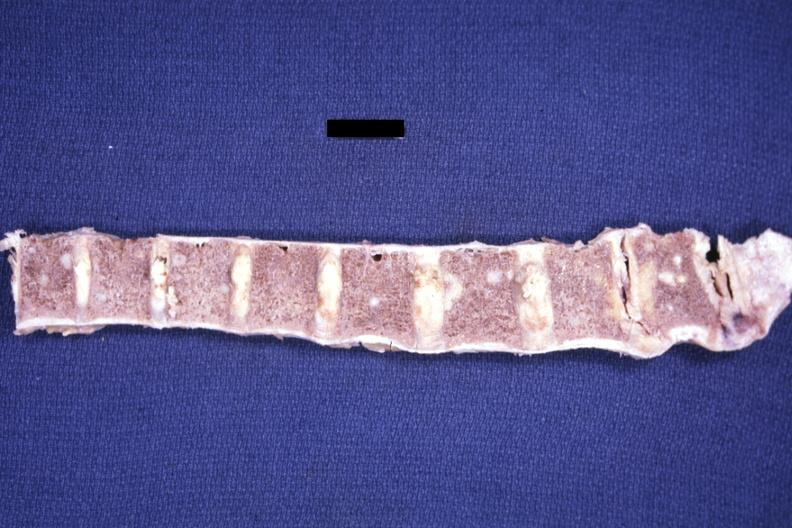does this image show fixed tissue easily seen metastases not the best photo technic adenoca from lung?
Answer the question using a single word or phrase. Yes 